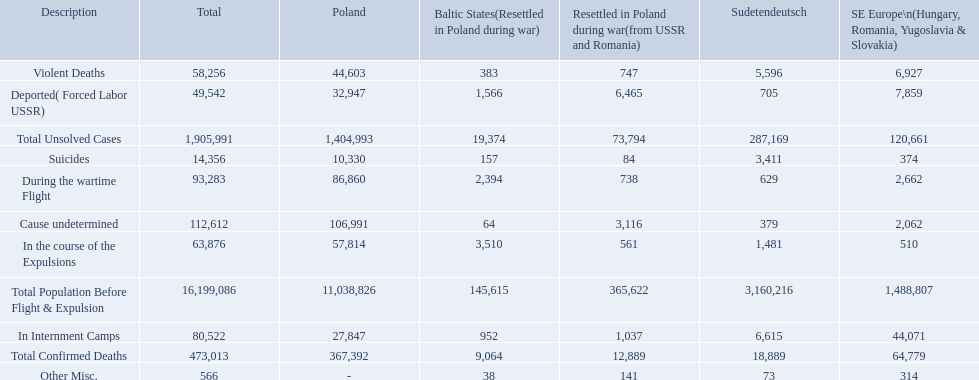What were all of the types of deaths? Violent Deaths, Suicides, Deported( Forced Labor USSR), In Internment Camps, During the wartime Flight, In the course of the Expulsions, Cause undetermined, Other Misc. And their totals in the baltic states? 383, 157, 1,566, 952, 2,394, 3,510, 64, 38. Were more deaths in the baltic states caused by undetermined causes or misc.? Cause undetermined. 